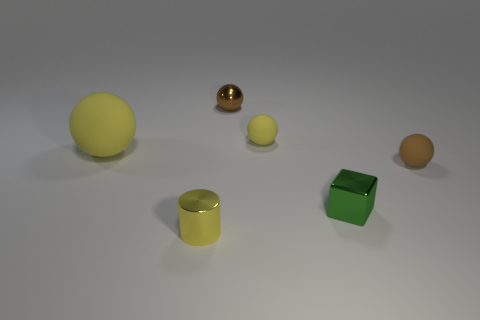What number of things are either small green metal cubes or tiny objects to the right of the tiny yellow shiny object?
Your response must be concise. 4. What material is the yellow sphere right of the yellow object that is in front of the tiny brown object that is in front of the big yellow object?
Make the answer very short. Rubber. What size is the other yellow sphere that is made of the same material as the small yellow ball?
Your answer should be compact. Large. What is the color of the sphere that is left of the object in front of the green metallic cube?
Provide a succinct answer. Yellow. How many tiny brown things are the same material as the cylinder?
Your answer should be compact. 1. What number of metallic objects are either tiny yellow things or large things?
Ensure brevity in your answer.  1. There is a yellow ball that is the same size as the green shiny object; what material is it?
Provide a succinct answer. Rubber. Is there a sphere made of the same material as the small green cube?
Offer a very short reply. Yes. What is the shape of the small yellow object that is right of the small brown thing that is behind the rubber thing that is in front of the large yellow sphere?
Offer a very short reply. Sphere. Does the green cube have the same size as the thing behind the tiny yellow matte sphere?
Provide a succinct answer. Yes. 